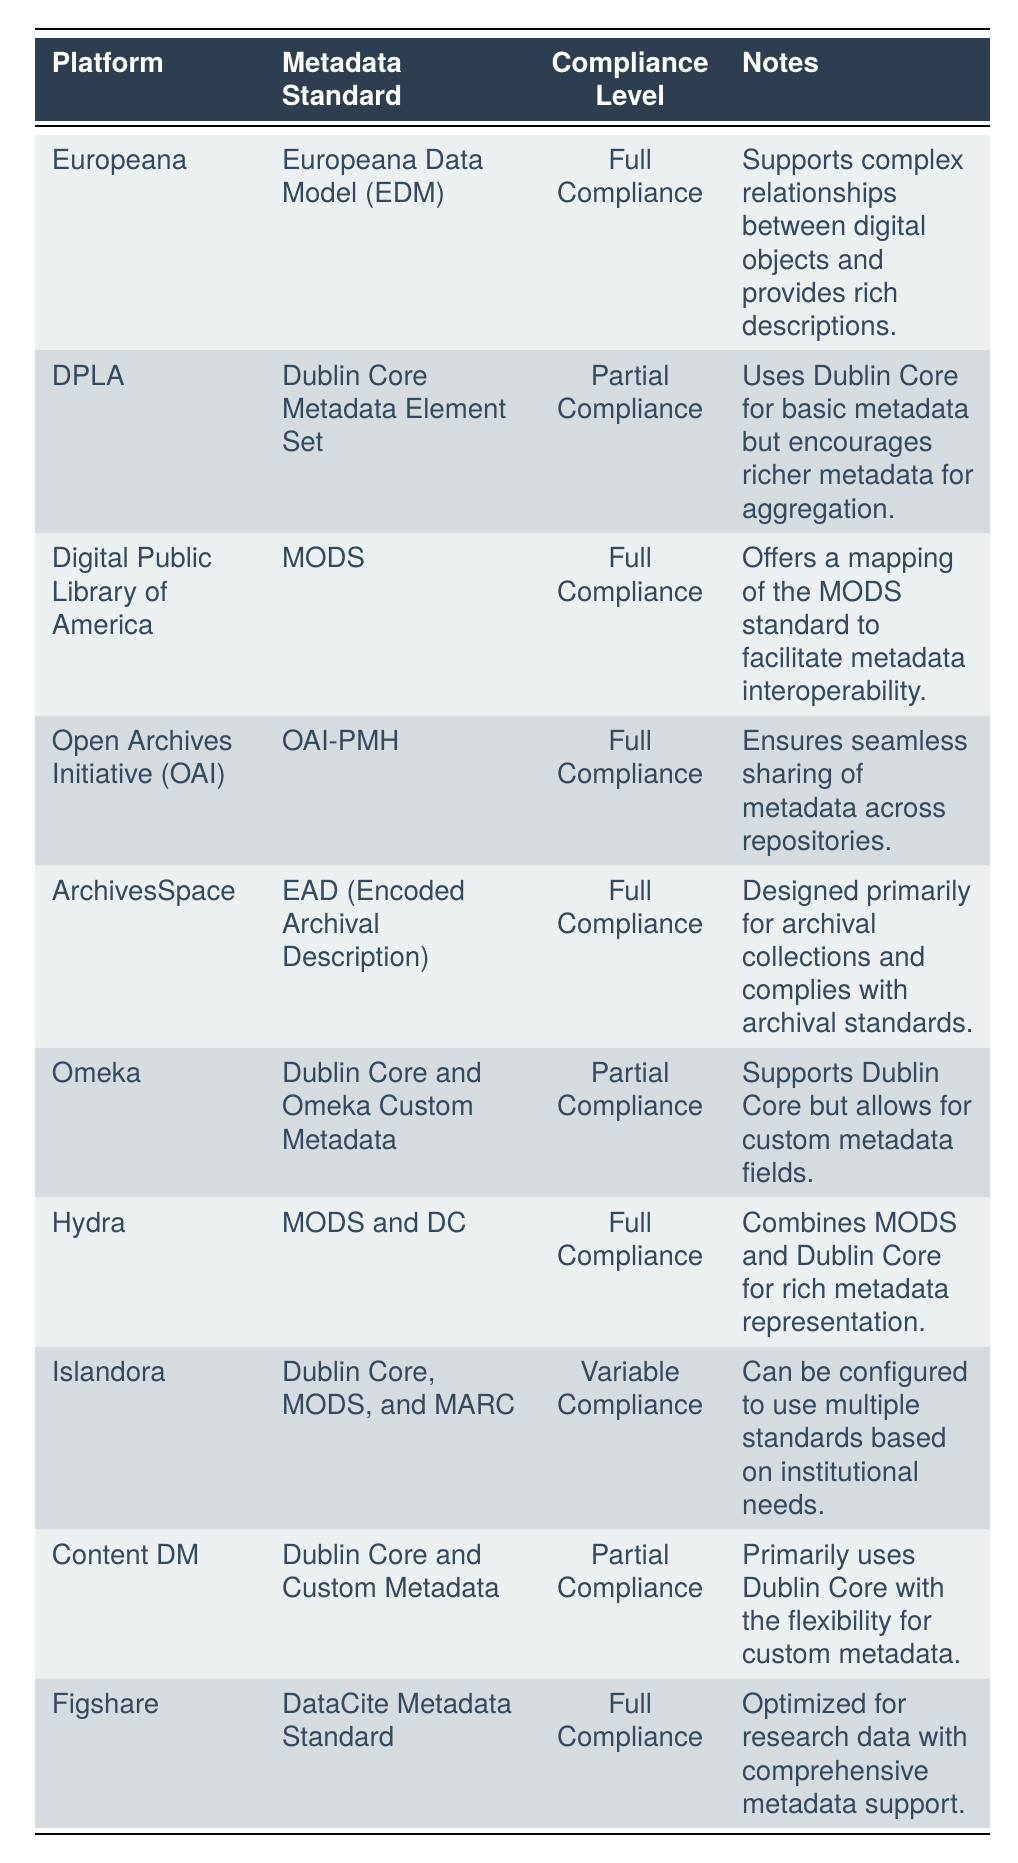What metadata standard does Europeana use? By looking at the table, we can find the row for Europeana, which indicates that it uses the Europeana Data Model (EDM) as its metadata standard.
Answer: Europeana Data Model (EDM) Which platform is fully compliant with the MODS standard? Referring to the table, we can see that both the Digital Public Library of America and Hydra have full compliance with the MODS standard. However, Digital Public Library of America is specifically mentioned for its full compliance with MODS.
Answer: Digital Public Library of America How many platforms use Dublin Core as part of their metadata standard? Counting the relevant platforms in the table, we find that DPLA, Omeka, Content DM, Islandora, and Hydra all use Dublin Core in their metadata standard. Therefore, there are a total of 5 platforms.
Answer: 5 Is Figshare compliant with any metadata standard? The table shows that Figshare is fully compliant with the DataCite Metadata Standard, which confirms that it is indeed compliant with a metadata standard.
Answer: Yes What is the compliance level of Islandora? We refer to the table and see that Islandora is listed with a compliance level of variable compliance, which indicates it can adapt to different standards based on settings.
Answer: Variable Compliance Are there more platforms with full compliance or partial compliance? In the table, we identify the platforms categorized under full compliance (6 platforms) and partial compliance (3 platforms). Since full compliance has the greater count, that confirms the answer.
Answer: Full compliance Which platform supports custom metadata fields? The table indicates Omeka supports Dublin Core along with custom metadata fields, providing a clear identification of such capability in the platform.
Answer: Omeka What does the compliance level 'Partial Compliance' mean in this context? Looking at the context in the table, ‘Partial Compliance’ indicates that the platform supports a basic metadata standard (like Dublin Core) but encourages or allows for additional, richer metadata to enhance compatibility.
Answer: Partial Compliance supports basic metadata but encourages richer metadata How do the notes for DPLA and Content DM compare in terms of metadata flexibility? In the table, DPLA notes that it makes use of Dublin Core for basic metadata while encouraging richer metadata for aggregation, whereas Content DM also primarily uses Dublin Core but allows flexibility for custom metadata. Both emphasize some level of flexibility, but Content DM explicitly states it allows custom fields.
Answer: Both offer some flexibility, but Content DM explicitly allows custom metadata fields 